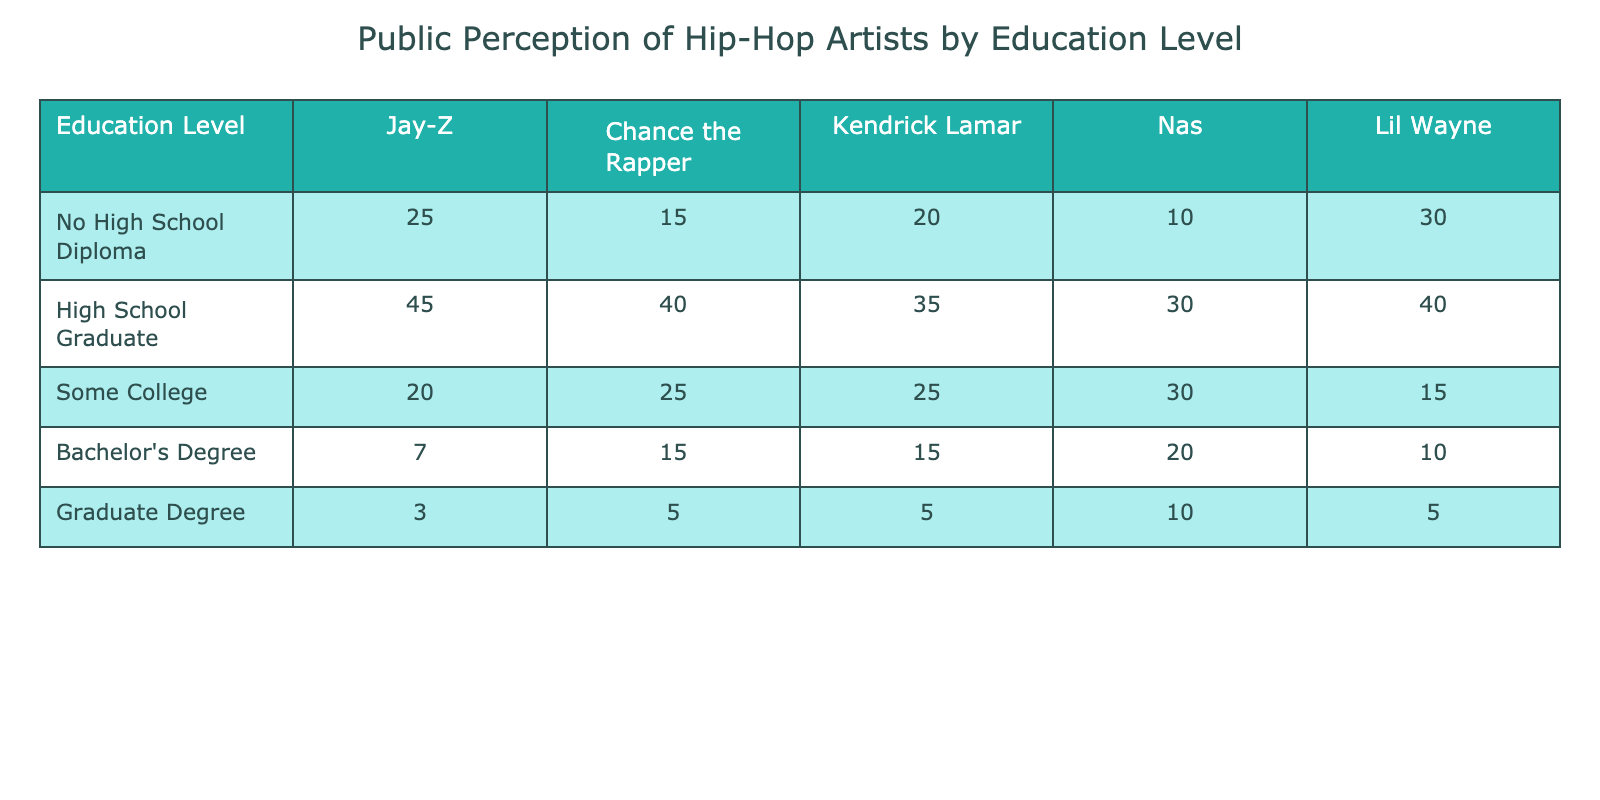What is the highest number of supporters for any artist among those without a high school diploma? Looking at the "No High School Diploma" row, Lil Wayne has the highest number of supporters, which is 30.
Answer: 30 Which artist has the lowest support among high school graduates? In the "High School Graduate" row, Kendrick Lamar has the lowest number of supporters with 35.
Answer: 35 What is the total number of supporters for Jay-Z across all education levels? Summing up the values in the Jay-Z column: 25 (No High School Diploma) + 45 (High School Graduate) + 20 (Some College) + 7 (Bachelor's Degree) + 3 (Graduate Degree) gives us a total of 100.
Answer: 100 Is it true that more than 50% of the supporters for Chance the Rapper are high school graduates? Chance the Rapper has 40 supporters who are high school graduates out of a total of 105 (15 + 40 + 25 + 15 + 5). 40/105 is approximately 38.1%, which is less than 50%.
Answer: No What is the combined total number of supporters for Kendrick Lamar and Nas with a graduate degree? Looking at the "Graduate Degree" row, Kendrick Lamar has 5 supporters and Nas has 10 supporters. Adding these together gives us 5 + 10 = 15.
Answer: 15 What percentage of supporters for Lil Wayne hold a Bachelor's Degree? In the "Bachelor's Degree" row, Lil Wayne has 10 supporters, and the total number of supporters across all education levels is 100 (30 + 40 + 15 + 10 + 5). The percentage is (10/100) * 100 = 10%.
Answer: 10% Which education level has the highest total number of supporters across all artists? To find this, we sum each column: No High School Diploma totals 100 (sum of 25, 15, 20, 10, 30), High School Graduate totals 190, Some College totals 115, Bachelor's Degree totals 55, and Graduate Degree totals 28. The highest total is from the High School Graduate category with 190.
Answer: High School Graduate How many more supporters does Nas have among high school graduates than among those with some college? Nas has 30 supporters among high school graduates and 30 among those with some college. The difference is 30 - 30 = 0.
Answer: 0 What is the average number of supporters for Chance the Rapper across all education levels? Summing Chance the Rapper's supporters: 15 + 40 + 25 + 15 + 5 = 100. There are 5 levels, so average is 100 / 5 = 20.
Answer: 20 